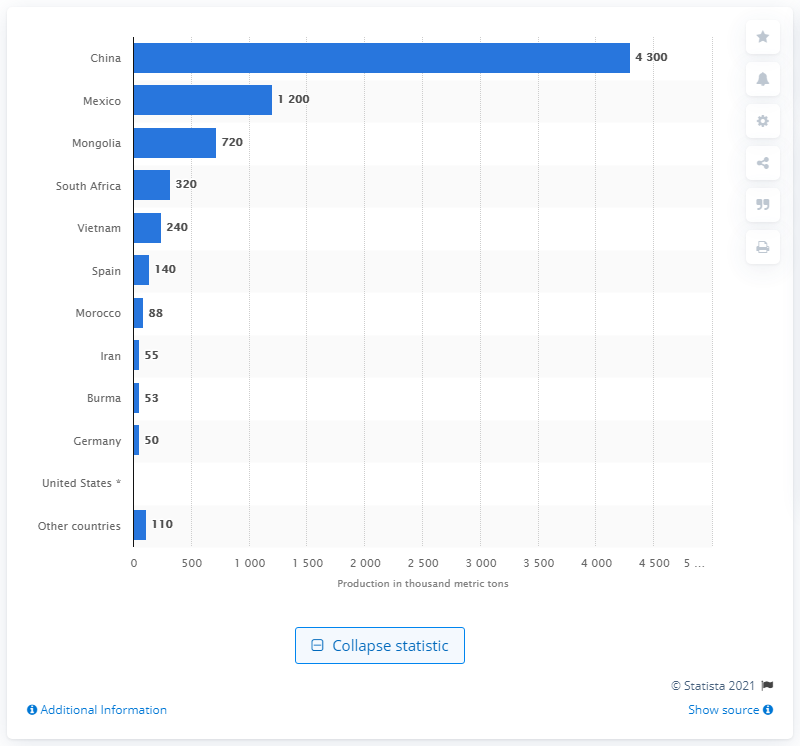Mention a couple of crucial points in this snapshot. As of 2020, China was the world's largest miner of fluorspar. 